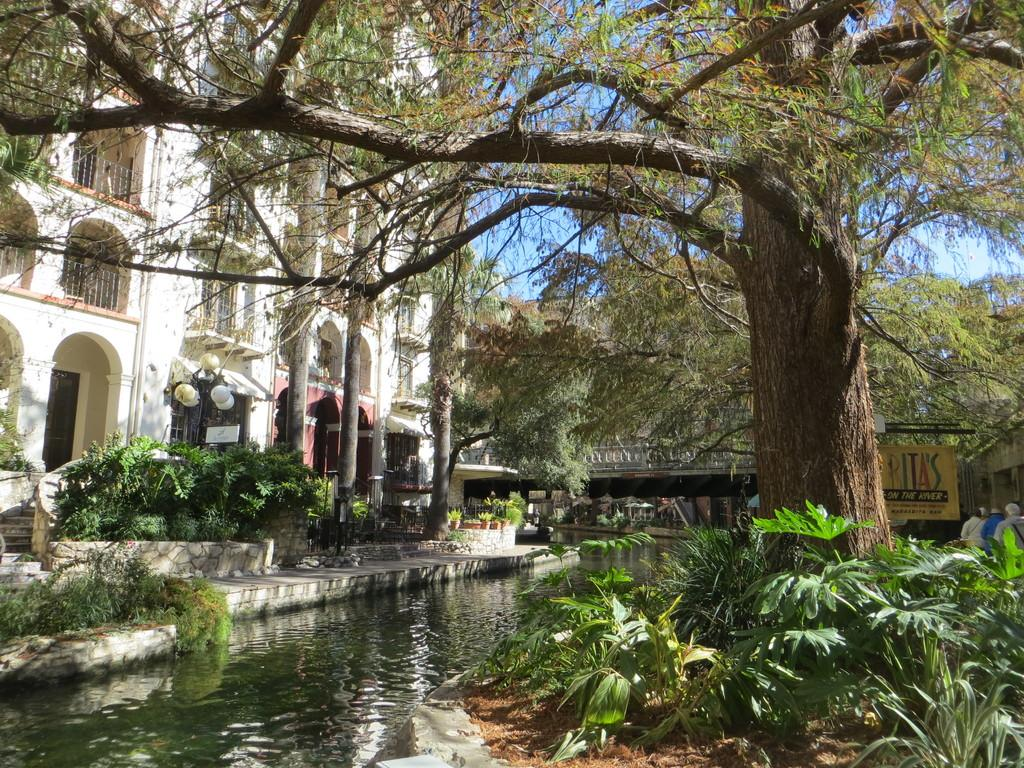What type of natural elements can be seen in the image? There are trees in the image. What type of man-made structure is present in the image? There is a building in the image. What body of water is visible in the image? There is water visible in the image. Can you describe any architectural features in the image? There is a staircase in the image. What type of lighting is present in the image? There is a light in the image. What type of transportation infrastructure is present in the image? There is a bridge in the image. What part of the natural environment is visible in the image? The sky is visible in the image. What type of volleyball court can be seen in the image? There is no volleyball court present in the image. What type of precipitation is falling from the sky in the image? The image does not depict any precipitation, such as sleet. 